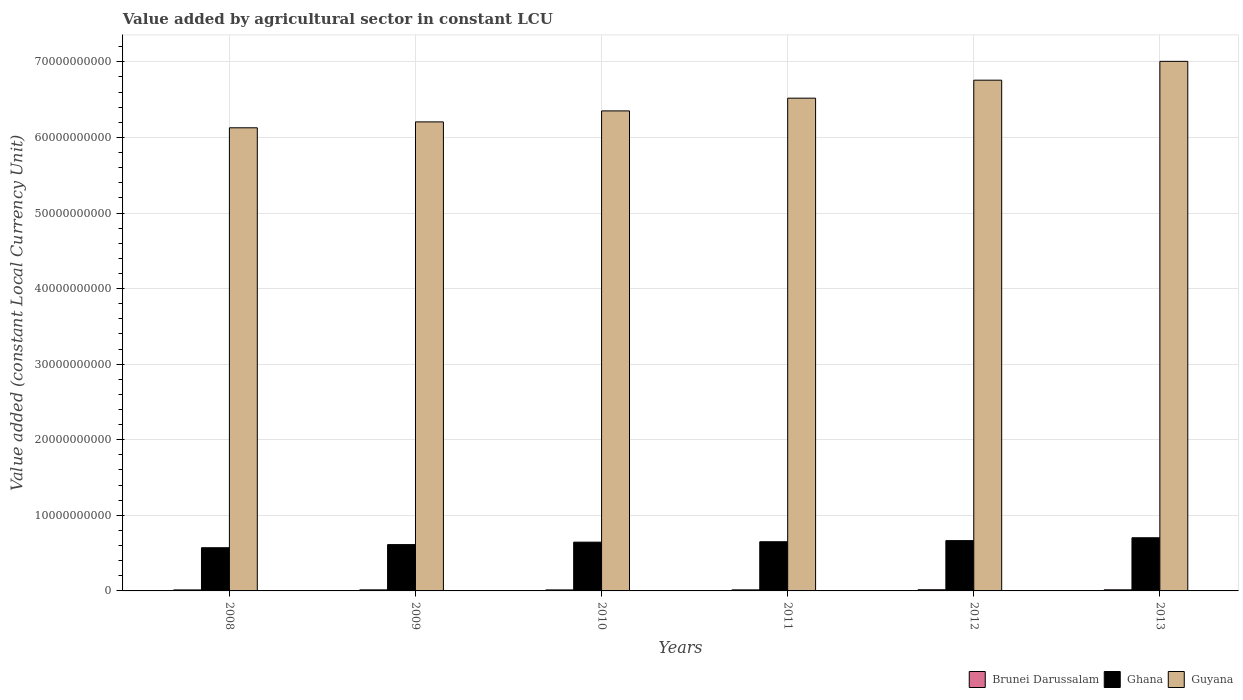Are the number of bars on each tick of the X-axis equal?
Your response must be concise. Yes. How many bars are there on the 2nd tick from the left?
Keep it short and to the point. 3. What is the label of the 5th group of bars from the left?
Offer a terse response. 2012. In how many cases, is the number of bars for a given year not equal to the number of legend labels?
Provide a succinct answer. 0. What is the value added by agricultural sector in Brunei Darussalam in 2011?
Your answer should be compact. 1.38e+08. Across all years, what is the maximum value added by agricultural sector in Brunei Darussalam?
Your response must be concise. 1.55e+08. Across all years, what is the minimum value added by agricultural sector in Ghana?
Provide a succinct answer. 5.72e+09. In which year was the value added by agricultural sector in Brunei Darussalam maximum?
Give a very brief answer. 2012. What is the total value added by agricultural sector in Brunei Darussalam in the graph?
Offer a terse response. 8.45e+08. What is the difference between the value added by agricultural sector in Brunei Darussalam in 2012 and that in 2013?
Offer a very short reply. 1.00e+07. What is the difference between the value added by agricultural sector in Guyana in 2008 and the value added by agricultural sector in Ghana in 2009?
Give a very brief answer. 5.52e+1. What is the average value added by agricultural sector in Brunei Darussalam per year?
Make the answer very short. 1.41e+08. In the year 2010, what is the difference between the value added by agricultural sector in Brunei Darussalam and value added by agricultural sector in Guyana?
Your answer should be very brief. -6.34e+1. In how many years, is the value added by agricultural sector in Ghana greater than 28000000000 LCU?
Provide a short and direct response. 0. What is the ratio of the value added by agricultural sector in Brunei Darussalam in 2008 to that in 2009?
Provide a succinct answer. 0.95. Is the value added by agricultural sector in Brunei Darussalam in 2008 less than that in 2013?
Keep it short and to the point. Yes. What is the difference between the highest and the second highest value added by agricultural sector in Guyana?
Offer a very short reply. 2.49e+09. What is the difference between the highest and the lowest value added by agricultural sector in Brunei Darussalam?
Provide a short and direct response. 2.24e+07. Is the sum of the value added by agricultural sector in Brunei Darussalam in 2008 and 2009 greater than the maximum value added by agricultural sector in Guyana across all years?
Offer a terse response. No. What does the 2nd bar from the right in 2011 represents?
Provide a succinct answer. Ghana. How many bars are there?
Keep it short and to the point. 18. How many years are there in the graph?
Give a very brief answer. 6. Does the graph contain any zero values?
Provide a succinct answer. No. How many legend labels are there?
Give a very brief answer. 3. How are the legend labels stacked?
Ensure brevity in your answer.  Horizontal. What is the title of the graph?
Keep it short and to the point. Value added by agricultural sector in constant LCU. What is the label or title of the Y-axis?
Your response must be concise. Value added (constant Local Currency Unit). What is the Value added (constant Local Currency Unit) of Brunei Darussalam in 2008?
Your answer should be very brief. 1.33e+08. What is the Value added (constant Local Currency Unit) of Ghana in 2008?
Your response must be concise. 5.72e+09. What is the Value added (constant Local Currency Unit) in Guyana in 2008?
Make the answer very short. 6.13e+1. What is the Value added (constant Local Currency Unit) of Brunei Darussalam in 2009?
Your answer should be very brief. 1.41e+08. What is the Value added (constant Local Currency Unit) of Ghana in 2009?
Offer a terse response. 6.13e+09. What is the Value added (constant Local Currency Unit) in Guyana in 2009?
Keep it short and to the point. 6.21e+1. What is the Value added (constant Local Currency Unit) in Brunei Darussalam in 2010?
Provide a short and direct response. 1.32e+08. What is the Value added (constant Local Currency Unit) in Ghana in 2010?
Keep it short and to the point. 6.45e+09. What is the Value added (constant Local Currency Unit) in Guyana in 2010?
Provide a short and direct response. 6.35e+1. What is the Value added (constant Local Currency Unit) of Brunei Darussalam in 2011?
Offer a terse response. 1.38e+08. What is the Value added (constant Local Currency Unit) of Ghana in 2011?
Give a very brief answer. 6.51e+09. What is the Value added (constant Local Currency Unit) of Guyana in 2011?
Your answer should be compact. 6.52e+1. What is the Value added (constant Local Currency Unit) of Brunei Darussalam in 2012?
Your response must be concise. 1.55e+08. What is the Value added (constant Local Currency Unit) in Ghana in 2012?
Ensure brevity in your answer.  6.66e+09. What is the Value added (constant Local Currency Unit) in Guyana in 2012?
Give a very brief answer. 6.76e+1. What is the Value added (constant Local Currency Unit) of Brunei Darussalam in 2013?
Keep it short and to the point. 1.45e+08. What is the Value added (constant Local Currency Unit) in Ghana in 2013?
Offer a terse response. 7.03e+09. What is the Value added (constant Local Currency Unit) in Guyana in 2013?
Your answer should be compact. 7.01e+1. Across all years, what is the maximum Value added (constant Local Currency Unit) in Brunei Darussalam?
Provide a short and direct response. 1.55e+08. Across all years, what is the maximum Value added (constant Local Currency Unit) in Ghana?
Give a very brief answer. 7.03e+09. Across all years, what is the maximum Value added (constant Local Currency Unit) of Guyana?
Provide a short and direct response. 7.01e+1. Across all years, what is the minimum Value added (constant Local Currency Unit) in Brunei Darussalam?
Provide a short and direct response. 1.32e+08. Across all years, what is the minimum Value added (constant Local Currency Unit) in Ghana?
Keep it short and to the point. 5.72e+09. Across all years, what is the minimum Value added (constant Local Currency Unit) of Guyana?
Offer a terse response. 6.13e+1. What is the total Value added (constant Local Currency Unit) of Brunei Darussalam in the graph?
Keep it short and to the point. 8.45e+08. What is the total Value added (constant Local Currency Unit) in Ghana in the graph?
Give a very brief answer. 3.85e+1. What is the total Value added (constant Local Currency Unit) of Guyana in the graph?
Make the answer very short. 3.90e+11. What is the difference between the Value added (constant Local Currency Unit) in Brunei Darussalam in 2008 and that in 2009?
Your answer should be compact. -7.60e+06. What is the difference between the Value added (constant Local Currency Unit) in Ghana in 2008 and that in 2009?
Give a very brief answer. -4.13e+08. What is the difference between the Value added (constant Local Currency Unit) in Guyana in 2008 and that in 2009?
Your answer should be compact. -7.80e+08. What is the difference between the Value added (constant Local Currency Unit) of Brunei Darussalam in 2008 and that in 2010?
Keep it short and to the point. 6.47e+05. What is the difference between the Value added (constant Local Currency Unit) in Ghana in 2008 and that in 2010?
Provide a short and direct response. -7.36e+08. What is the difference between the Value added (constant Local Currency Unit) in Guyana in 2008 and that in 2010?
Offer a terse response. -2.23e+09. What is the difference between the Value added (constant Local Currency Unit) of Brunei Darussalam in 2008 and that in 2011?
Keep it short and to the point. -5.40e+06. What is the difference between the Value added (constant Local Currency Unit) in Ghana in 2008 and that in 2011?
Provide a short and direct response. -7.91e+08. What is the difference between the Value added (constant Local Currency Unit) of Guyana in 2008 and that in 2011?
Your answer should be very brief. -3.92e+09. What is the difference between the Value added (constant Local Currency Unit) of Brunei Darussalam in 2008 and that in 2012?
Offer a terse response. -2.18e+07. What is the difference between the Value added (constant Local Currency Unit) in Ghana in 2008 and that in 2012?
Provide a succinct answer. -9.41e+08. What is the difference between the Value added (constant Local Currency Unit) of Guyana in 2008 and that in 2012?
Give a very brief answer. -6.30e+09. What is the difference between the Value added (constant Local Currency Unit) of Brunei Darussalam in 2008 and that in 2013?
Ensure brevity in your answer.  -1.18e+07. What is the difference between the Value added (constant Local Currency Unit) in Ghana in 2008 and that in 2013?
Your answer should be very brief. -1.32e+09. What is the difference between the Value added (constant Local Currency Unit) of Guyana in 2008 and that in 2013?
Give a very brief answer. -8.79e+09. What is the difference between the Value added (constant Local Currency Unit) in Brunei Darussalam in 2009 and that in 2010?
Your answer should be compact. 8.25e+06. What is the difference between the Value added (constant Local Currency Unit) of Ghana in 2009 and that in 2010?
Your answer should be compact. -3.23e+08. What is the difference between the Value added (constant Local Currency Unit) in Guyana in 2009 and that in 2010?
Make the answer very short. -1.45e+09. What is the difference between the Value added (constant Local Currency Unit) of Brunei Darussalam in 2009 and that in 2011?
Offer a very short reply. 2.20e+06. What is the difference between the Value added (constant Local Currency Unit) in Ghana in 2009 and that in 2011?
Offer a terse response. -3.78e+08. What is the difference between the Value added (constant Local Currency Unit) of Guyana in 2009 and that in 2011?
Make the answer very short. -3.14e+09. What is the difference between the Value added (constant Local Currency Unit) of Brunei Darussalam in 2009 and that in 2012?
Make the answer very short. -1.42e+07. What is the difference between the Value added (constant Local Currency Unit) of Ghana in 2009 and that in 2012?
Give a very brief answer. -5.28e+08. What is the difference between the Value added (constant Local Currency Unit) of Guyana in 2009 and that in 2012?
Offer a terse response. -5.52e+09. What is the difference between the Value added (constant Local Currency Unit) in Brunei Darussalam in 2009 and that in 2013?
Offer a very short reply. -4.20e+06. What is the difference between the Value added (constant Local Currency Unit) in Ghana in 2009 and that in 2013?
Your response must be concise. -9.06e+08. What is the difference between the Value added (constant Local Currency Unit) in Guyana in 2009 and that in 2013?
Give a very brief answer. -8.01e+09. What is the difference between the Value added (constant Local Currency Unit) of Brunei Darussalam in 2010 and that in 2011?
Offer a terse response. -6.05e+06. What is the difference between the Value added (constant Local Currency Unit) in Ghana in 2010 and that in 2011?
Offer a terse response. -5.46e+07. What is the difference between the Value added (constant Local Currency Unit) of Guyana in 2010 and that in 2011?
Keep it short and to the point. -1.68e+09. What is the difference between the Value added (constant Local Currency Unit) of Brunei Darussalam in 2010 and that in 2012?
Provide a short and direct response. -2.24e+07. What is the difference between the Value added (constant Local Currency Unit) in Ghana in 2010 and that in 2012?
Your answer should be very brief. -2.04e+08. What is the difference between the Value added (constant Local Currency Unit) in Guyana in 2010 and that in 2012?
Make the answer very short. -4.06e+09. What is the difference between the Value added (constant Local Currency Unit) in Brunei Darussalam in 2010 and that in 2013?
Keep it short and to the point. -1.24e+07. What is the difference between the Value added (constant Local Currency Unit) of Ghana in 2010 and that in 2013?
Provide a succinct answer. -5.82e+08. What is the difference between the Value added (constant Local Currency Unit) of Guyana in 2010 and that in 2013?
Offer a terse response. -6.56e+09. What is the difference between the Value added (constant Local Currency Unit) of Brunei Darussalam in 2011 and that in 2012?
Provide a succinct answer. -1.64e+07. What is the difference between the Value added (constant Local Currency Unit) in Ghana in 2011 and that in 2012?
Offer a terse response. -1.50e+08. What is the difference between the Value added (constant Local Currency Unit) of Guyana in 2011 and that in 2012?
Your answer should be very brief. -2.38e+09. What is the difference between the Value added (constant Local Currency Unit) in Brunei Darussalam in 2011 and that in 2013?
Provide a short and direct response. -6.40e+06. What is the difference between the Value added (constant Local Currency Unit) in Ghana in 2011 and that in 2013?
Your answer should be compact. -5.28e+08. What is the difference between the Value added (constant Local Currency Unit) of Guyana in 2011 and that in 2013?
Offer a very short reply. -4.87e+09. What is the difference between the Value added (constant Local Currency Unit) in Brunei Darussalam in 2012 and that in 2013?
Offer a very short reply. 1.00e+07. What is the difference between the Value added (constant Local Currency Unit) in Ghana in 2012 and that in 2013?
Keep it short and to the point. -3.78e+08. What is the difference between the Value added (constant Local Currency Unit) in Guyana in 2012 and that in 2013?
Keep it short and to the point. -2.49e+09. What is the difference between the Value added (constant Local Currency Unit) of Brunei Darussalam in 2008 and the Value added (constant Local Currency Unit) of Ghana in 2009?
Your response must be concise. -6.00e+09. What is the difference between the Value added (constant Local Currency Unit) in Brunei Darussalam in 2008 and the Value added (constant Local Currency Unit) in Guyana in 2009?
Your answer should be compact. -6.19e+1. What is the difference between the Value added (constant Local Currency Unit) in Ghana in 2008 and the Value added (constant Local Currency Unit) in Guyana in 2009?
Ensure brevity in your answer.  -5.63e+1. What is the difference between the Value added (constant Local Currency Unit) in Brunei Darussalam in 2008 and the Value added (constant Local Currency Unit) in Ghana in 2010?
Keep it short and to the point. -6.32e+09. What is the difference between the Value added (constant Local Currency Unit) in Brunei Darussalam in 2008 and the Value added (constant Local Currency Unit) in Guyana in 2010?
Your response must be concise. -6.34e+1. What is the difference between the Value added (constant Local Currency Unit) of Ghana in 2008 and the Value added (constant Local Currency Unit) of Guyana in 2010?
Provide a succinct answer. -5.78e+1. What is the difference between the Value added (constant Local Currency Unit) of Brunei Darussalam in 2008 and the Value added (constant Local Currency Unit) of Ghana in 2011?
Your answer should be very brief. -6.37e+09. What is the difference between the Value added (constant Local Currency Unit) in Brunei Darussalam in 2008 and the Value added (constant Local Currency Unit) in Guyana in 2011?
Keep it short and to the point. -6.51e+1. What is the difference between the Value added (constant Local Currency Unit) of Ghana in 2008 and the Value added (constant Local Currency Unit) of Guyana in 2011?
Your answer should be compact. -5.95e+1. What is the difference between the Value added (constant Local Currency Unit) of Brunei Darussalam in 2008 and the Value added (constant Local Currency Unit) of Ghana in 2012?
Your answer should be compact. -6.52e+09. What is the difference between the Value added (constant Local Currency Unit) of Brunei Darussalam in 2008 and the Value added (constant Local Currency Unit) of Guyana in 2012?
Offer a very short reply. -6.74e+1. What is the difference between the Value added (constant Local Currency Unit) of Ghana in 2008 and the Value added (constant Local Currency Unit) of Guyana in 2012?
Provide a succinct answer. -6.19e+1. What is the difference between the Value added (constant Local Currency Unit) of Brunei Darussalam in 2008 and the Value added (constant Local Currency Unit) of Ghana in 2013?
Offer a very short reply. -6.90e+09. What is the difference between the Value added (constant Local Currency Unit) in Brunei Darussalam in 2008 and the Value added (constant Local Currency Unit) in Guyana in 2013?
Offer a very short reply. -6.99e+1. What is the difference between the Value added (constant Local Currency Unit) of Ghana in 2008 and the Value added (constant Local Currency Unit) of Guyana in 2013?
Offer a very short reply. -6.44e+1. What is the difference between the Value added (constant Local Currency Unit) in Brunei Darussalam in 2009 and the Value added (constant Local Currency Unit) in Ghana in 2010?
Provide a succinct answer. -6.31e+09. What is the difference between the Value added (constant Local Currency Unit) in Brunei Darussalam in 2009 and the Value added (constant Local Currency Unit) in Guyana in 2010?
Ensure brevity in your answer.  -6.34e+1. What is the difference between the Value added (constant Local Currency Unit) in Ghana in 2009 and the Value added (constant Local Currency Unit) in Guyana in 2010?
Your answer should be compact. -5.74e+1. What is the difference between the Value added (constant Local Currency Unit) in Brunei Darussalam in 2009 and the Value added (constant Local Currency Unit) in Ghana in 2011?
Offer a very short reply. -6.37e+09. What is the difference between the Value added (constant Local Currency Unit) in Brunei Darussalam in 2009 and the Value added (constant Local Currency Unit) in Guyana in 2011?
Offer a terse response. -6.51e+1. What is the difference between the Value added (constant Local Currency Unit) in Ghana in 2009 and the Value added (constant Local Currency Unit) in Guyana in 2011?
Make the answer very short. -5.91e+1. What is the difference between the Value added (constant Local Currency Unit) of Brunei Darussalam in 2009 and the Value added (constant Local Currency Unit) of Ghana in 2012?
Give a very brief answer. -6.52e+09. What is the difference between the Value added (constant Local Currency Unit) in Brunei Darussalam in 2009 and the Value added (constant Local Currency Unit) in Guyana in 2012?
Offer a very short reply. -6.74e+1. What is the difference between the Value added (constant Local Currency Unit) of Ghana in 2009 and the Value added (constant Local Currency Unit) of Guyana in 2012?
Offer a very short reply. -6.14e+1. What is the difference between the Value added (constant Local Currency Unit) in Brunei Darussalam in 2009 and the Value added (constant Local Currency Unit) in Ghana in 2013?
Provide a short and direct response. -6.89e+09. What is the difference between the Value added (constant Local Currency Unit) in Brunei Darussalam in 2009 and the Value added (constant Local Currency Unit) in Guyana in 2013?
Your answer should be compact. -6.99e+1. What is the difference between the Value added (constant Local Currency Unit) of Ghana in 2009 and the Value added (constant Local Currency Unit) of Guyana in 2013?
Ensure brevity in your answer.  -6.39e+1. What is the difference between the Value added (constant Local Currency Unit) of Brunei Darussalam in 2010 and the Value added (constant Local Currency Unit) of Ghana in 2011?
Provide a short and direct response. -6.37e+09. What is the difference between the Value added (constant Local Currency Unit) of Brunei Darussalam in 2010 and the Value added (constant Local Currency Unit) of Guyana in 2011?
Keep it short and to the point. -6.51e+1. What is the difference between the Value added (constant Local Currency Unit) of Ghana in 2010 and the Value added (constant Local Currency Unit) of Guyana in 2011?
Give a very brief answer. -5.87e+1. What is the difference between the Value added (constant Local Currency Unit) of Brunei Darussalam in 2010 and the Value added (constant Local Currency Unit) of Ghana in 2012?
Provide a short and direct response. -6.52e+09. What is the difference between the Value added (constant Local Currency Unit) in Brunei Darussalam in 2010 and the Value added (constant Local Currency Unit) in Guyana in 2012?
Provide a short and direct response. -6.74e+1. What is the difference between the Value added (constant Local Currency Unit) in Ghana in 2010 and the Value added (constant Local Currency Unit) in Guyana in 2012?
Offer a terse response. -6.11e+1. What is the difference between the Value added (constant Local Currency Unit) of Brunei Darussalam in 2010 and the Value added (constant Local Currency Unit) of Ghana in 2013?
Ensure brevity in your answer.  -6.90e+09. What is the difference between the Value added (constant Local Currency Unit) in Brunei Darussalam in 2010 and the Value added (constant Local Currency Unit) in Guyana in 2013?
Offer a very short reply. -6.99e+1. What is the difference between the Value added (constant Local Currency Unit) in Ghana in 2010 and the Value added (constant Local Currency Unit) in Guyana in 2013?
Make the answer very short. -6.36e+1. What is the difference between the Value added (constant Local Currency Unit) in Brunei Darussalam in 2011 and the Value added (constant Local Currency Unit) in Ghana in 2012?
Your answer should be compact. -6.52e+09. What is the difference between the Value added (constant Local Currency Unit) of Brunei Darussalam in 2011 and the Value added (constant Local Currency Unit) of Guyana in 2012?
Keep it short and to the point. -6.74e+1. What is the difference between the Value added (constant Local Currency Unit) of Ghana in 2011 and the Value added (constant Local Currency Unit) of Guyana in 2012?
Give a very brief answer. -6.11e+1. What is the difference between the Value added (constant Local Currency Unit) in Brunei Darussalam in 2011 and the Value added (constant Local Currency Unit) in Ghana in 2013?
Keep it short and to the point. -6.90e+09. What is the difference between the Value added (constant Local Currency Unit) of Brunei Darussalam in 2011 and the Value added (constant Local Currency Unit) of Guyana in 2013?
Provide a succinct answer. -6.99e+1. What is the difference between the Value added (constant Local Currency Unit) of Ghana in 2011 and the Value added (constant Local Currency Unit) of Guyana in 2013?
Your answer should be very brief. -6.36e+1. What is the difference between the Value added (constant Local Currency Unit) of Brunei Darussalam in 2012 and the Value added (constant Local Currency Unit) of Ghana in 2013?
Ensure brevity in your answer.  -6.88e+09. What is the difference between the Value added (constant Local Currency Unit) in Brunei Darussalam in 2012 and the Value added (constant Local Currency Unit) in Guyana in 2013?
Your answer should be compact. -6.99e+1. What is the difference between the Value added (constant Local Currency Unit) in Ghana in 2012 and the Value added (constant Local Currency Unit) in Guyana in 2013?
Make the answer very short. -6.34e+1. What is the average Value added (constant Local Currency Unit) in Brunei Darussalam per year?
Offer a very short reply. 1.41e+08. What is the average Value added (constant Local Currency Unit) of Ghana per year?
Keep it short and to the point. 6.42e+09. What is the average Value added (constant Local Currency Unit) of Guyana per year?
Make the answer very short. 6.50e+1. In the year 2008, what is the difference between the Value added (constant Local Currency Unit) in Brunei Darussalam and Value added (constant Local Currency Unit) in Ghana?
Provide a short and direct response. -5.58e+09. In the year 2008, what is the difference between the Value added (constant Local Currency Unit) of Brunei Darussalam and Value added (constant Local Currency Unit) of Guyana?
Keep it short and to the point. -6.11e+1. In the year 2008, what is the difference between the Value added (constant Local Currency Unit) of Ghana and Value added (constant Local Currency Unit) of Guyana?
Your answer should be compact. -5.56e+1. In the year 2009, what is the difference between the Value added (constant Local Currency Unit) in Brunei Darussalam and Value added (constant Local Currency Unit) in Ghana?
Your answer should be compact. -5.99e+09. In the year 2009, what is the difference between the Value added (constant Local Currency Unit) in Brunei Darussalam and Value added (constant Local Currency Unit) in Guyana?
Provide a short and direct response. -6.19e+1. In the year 2009, what is the difference between the Value added (constant Local Currency Unit) of Ghana and Value added (constant Local Currency Unit) of Guyana?
Provide a short and direct response. -5.59e+1. In the year 2010, what is the difference between the Value added (constant Local Currency Unit) of Brunei Darussalam and Value added (constant Local Currency Unit) of Ghana?
Your answer should be very brief. -6.32e+09. In the year 2010, what is the difference between the Value added (constant Local Currency Unit) of Brunei Darussalam and Value added (constant Local Currency Unit) of Guyana?
Keep it short and to the point. -6.34e+1. In the year 2010, what is the difference between the Value added (constant Local Currency Unit) of Ghana and Value added (constant Local Currency Unit) of Guyana?
Your answer should be very brief. -5.71e+1. In the year 2011, what is the difference between the Value added (constant Local Currency Unit) in Brunei Darussalam and Value added (constant Local Currency Unit) in Ghana?
Keep it short and to the point. -6.37e+09. In the year 2011, what is the difference between the Value added (constant Local Currency Unit) of Brunei Darussalam and Value added (constant Local Currency Unit) of Guyana?
Your response must be concise. -6.51e+1. In the year 2011, what is the difference between the Value added (constant Local Currency Unit) of Ghana and Value added (constant Local Currency Unit) of Guyana?
Provide a short and direct response. -5.87e+1. In the year 2012, what is the difference between the Value added (constant Local Currency Unit) in Brunei Darussalam and Value added (constant Local Currency Unit) in Ghana?
Ensure brevity in your answer.  -6.50e+09. In the year 2012, what is the difference between the Value added (constant Local Currency Unit) in Brunei Darussalam and Value added (constant Local Currency Unit) in Guyana?
Your answer should be compact. -6.74e+1. In the year 2012, what is the difference between the Value added (constant Local Currency Unit) in Ghana and Value added (constant Local Currency Unit) in Guyana?
Your answer should be compact. -6.09e+1. In the year 2013, what is the difference between the Value added (constant Local Currency Unit) of Brunei Darussalam and Value added (constant Local Currency Unit) of Ghana?
Your response must be concise. -6.89e+09. In the year 2013, what is the difference between the Value added (constant Local Currency Unit) of Brunei Darussalam and Value added (constant Local Currency Unit) of Guyana?
Your answer should be very brief. -6.99e+1. In the year 2013, what is the difference between the Value added (constant Local Currency Unit) in Ghana and Value added (constant Local Currency Unit) in Guyana?
Make the answer very short. -6.30e+1. What is the ratio of the Value added (constant Local Currency Unit) in Brunei Darussalam in 2008 to that in 2009?
Make the answer very short. 0.95. What is the ratio of the Value added (constant Local Currency Unit) of Ghana in 2008 to that in 2009?
Ensure brevity in your answer.  0.93. What is the ratio of the Value added (constant Local Currency Unit) of Guyana in 2008 to that in 2009?
Offer a very short reply. 0.99. What is the ratio of the Value added (constant Local Currency Unit) in Ghana in 2008 to that in 2010?
Ensure brevity in your answer.  0.89. What is the ratio of the Value added (constant Local Currency Unit) of Guyana in 2008 to that in 2010?
Provide a succinct answer. 0.96. What is the ratio of the Value added (constant Local Currency Unit) in Ghana in 2008 to that in 2011?
Provide a succinct answer. 0.88. What is the ratio of the Value added (constant Local Currency Unit) in Guyana in 2008 to that in 2011?
Give a very brief answer. 0.94. What is the ratio of the Value added (constant Local Currency Unit) in Brunei Darussalam in 2008 to that in 2012?
Keep it short and to the point. 0.86. What is the ratio of the Value added (constant Local Currency Unit) of Ghana in 2008 to that in 2012?
Your answer should be compact. 0.86. What is the ratio of the Value added (constant Local Currency Unit) in Guyana in 2008 to that in 2012?
Give a very brief answer. 0.91. What is the ratio of the Value added (constant Local Currency Unit) of Brunei Darussalam in 2008 to that in 2013?
Offer a very short reply. 0.92. What is the ratio of the Value added (constant Local Currency Unit) of Ghana in 2008 to that in 2013?
Ensure brevity in your answer.  0.81. What is the ratio of the Value added (constant Local Currency Unit) in Guyana in 2008 to that in 2013?
Give a very brief answer. 0.87. What is the ratio of the Value added (constant Local Currency Unit) in Brunei Darussalam in 2009 to that in 2010?
Ensure brevity in your answer.  1.06. What is the ratio of the Value added (constant Local Currency Unit) of Ghana in 2009 to that in 2010?
Keep it short and to the point. 0.95. What is the ratio of the Value added (constant Local Currency Unit) of Guyana in 2009 to that in 2010?
Your answer should be very brief. 0.98. What is the ratio of the Value added (constant Local Currency Unit) of Brunei Darussalam in 2009 to that in 2011?
Keep it short and to the point. 1.02. What is the ratio of the Value added (constant Local Currency Unit) in Ghana in 2009 to that in 2011?
Give a very brief answer. 0.94. What is the ratio of the Value added (constant Local Currency Unit) in Guyana in 2009 to that in 2011?
Keep it short and to the point. 0.95. What is the ratio of the Value added (constant Local Currency Unit) in Brunei Darussalam in 2009 to that in 2012?
Provide a succinct answer. 0.91. What is the ratio of the Value added (constant Local Currency Unit) in Ghana in 2009 to that in 2012?
Provide a succinct answer. 0.92. What is the ratio of the Value added (constant Local Currency Unit) of Guyana in 2009 to that in 2012?
Your response must be concise. 0.92. What is the ratio of the Value added (constant Local Currency Unit) in Ghana in 2009 to that in 2013?
Keep it short and to the point. 0.87. What is the ratio of the Value added (constant Local Currency Unit) of Guyana in 2009 to that in 2013?
Ensure brevity in your answer.  0.89. What is the ratio of the Value added (constant Local Currency Unit) in Brunei Darussalam in 2010 to that in 2011?
Offer a very short reply. 0.96. What is the ratio of the Value added (constant Local Currency Unit) of Guyana in 2010 to that in 2011?
Your answer should be very brief. 0.97. What is the ratio of the Value added (constant Local Currency Unit) of Brunei Darussalam in 2010 to that in 2012?
Make the answer very short. 0.86. What is the ratio of the Value added (constant Local Currency Unit) in Ghana in 2010 to that in 2012?
Make the answer very short. 0.97. What is the ratio of the Value added (constant Local Currency Unit) of Guyana in 2010 to that in 2012?
Your answer should be very brief. 0.94. What is the ratio of the Value added (constant Local Currency Unit) in Brunei Darussalam in 2010 to that in 2013?
Offer a very short reply. 0.91. What is the ratio of the Value added (constant Local Currency Unit) in Ghana in 2010 to that in 2013?
Ensure brevity in your answer.  0.92. What is the ratio of the Value added (constant Local Currency Unit) of Guyana in 2010 to that in 2013?
Your answer should be compact. 0.91. What is the ratio of the Value added (constant Local Currency Unit) of Brunei Darussalam in 2011 to that in 2012?
Give a very brief answer. 0.89. What is the ratio of the Value added (constant Local Currency Unit) in Ghana in 2011 to that in 2012?
Keep it short and to the point. 0.98. What is the ratio of the Value added (constant Local Currency Unit) in Guyana in 2011 to that in 2012?
Your response must be concise. 0.96. What is the ratio of the Value added (constant Local Currency Unit) of Brunei Darussalam in 2011 to that in 2013?
Make the answer very short. 0.96. What is the ratio of the Value added (constant Local Currency Unit) in Ghana in 2011 to that in 2013?
Ensure brevity in your answer.  0.93. What is the ratio of the Value added (constant Local Currency Unit) in Guyana in 2011 to that in 2013?
Keep it short and to the point. 0.93. What is the ratio of the Value added (constant Local Currency Unit) of Brunei Darussalam in 2012 to that in 2013?
Provide a short and direct response. 1.07. What is the ratio of the Value added (constant Local Currency Unit) of Ghana in 2012 to that in 2013?
Keep it short and to the point. 0.95. What is the ratio of the Value added (constant Local Currency Unit) of Guyana in 2012 to that in 2013?
Your answer should be compact. 0.96. What is the difference between the highest and the second highest Value added (constant Local Currency Unit) in Brunei Darussalam?
Your response must be concise. 1.00e+07. What is the difference between the highest and the second highest Value added (constant Local Currency Unit) of Ghana?
Your response must be concise. 3.78e+08. What is the difference between the highest and the second highest Value added (constant Local Currency Unit) in Guyana?
Your answer should be compact. 2.49e+09. What is the difference between the highest and the lowest Value added (constant Local Currency Unit) in Brunei Darussalam?
Your response must be concise. 2.24e+07. What is the difference between the highest and the lowest Value added (constant Local Currency Unit) of Ghana?
Your response must be concise. 1.32e+09. What is the difference between the highest and the lowest Value added (constant Local Currency Unit) in Guyana?
Your answer should be very brief. 8.79e+09. 